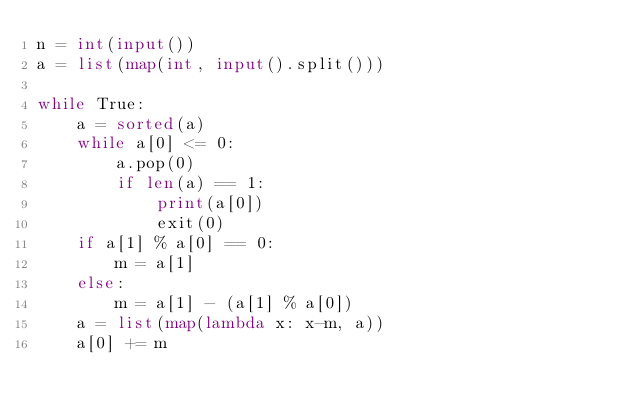Convert code to text. <code><loc_0><loc_0><loc_500><loc_500><_Python_>n = int(input())
a = list(map(int, input().split()))

while True:
    a = sorted(a)
    while a[0] <= 0:
        a.pop(0)
        if len(a) == 1:
            print(a[0])
            exit(0)
    if a[1] % a[0] == 0:
        m = a[1]
    else:
        m = a[1] - (a[1] % a[0])
    a = list(map(lambda x: x-m, a))
    a[0] += m
</code> 